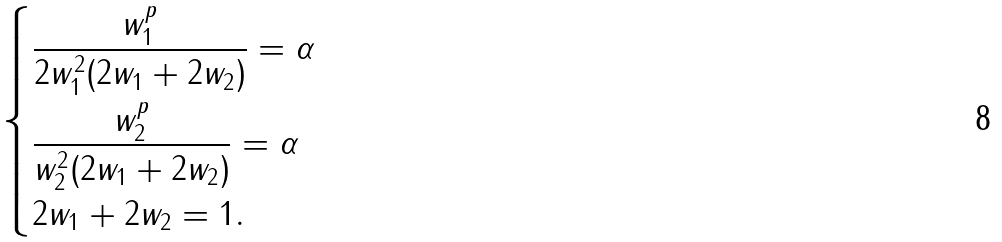<formula> <loc_0><loc_0><loc_500><loc_500>\begin{dcases} \frac { w _ { 1 } ^ { p } } { 2 w _ { 1 } ^ { 2 } ( 2 w _ { 1 } + 2 w _ { 2 } ) } = \alpha \\ \frac { w _ { 2 } ^ { p } } { w _ { 2 } ^ { 2 } ( 2 w _ { 1 } + 2 w _ { 2 } ) } = \alpha \\ 2 w _ { 1 } + 2 w _ { 2 } = 1 . \end{dcases}</formula> 